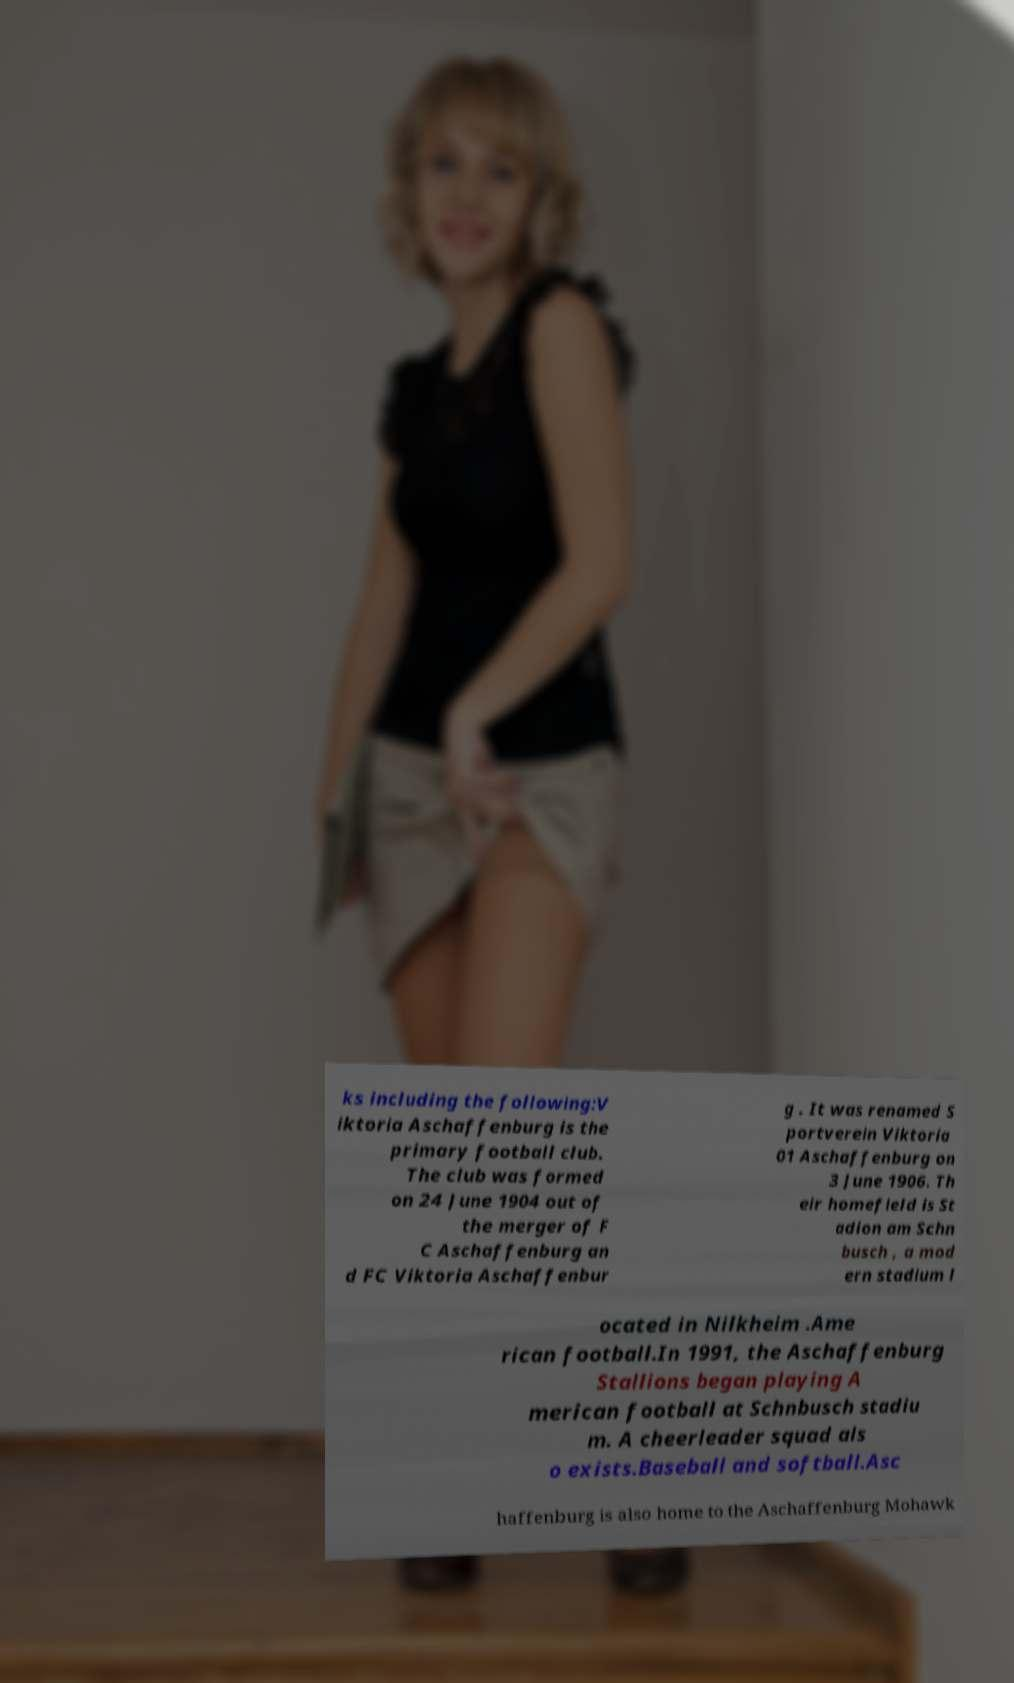I need the written content from this picture converted into text. Can you do that? ks including the following:V iktoria Aschaffenburg is the primary football club. The club was formed on 24 June 1904 out of the merger of F C Aschaffenburg an d FC Viktoria Aschaffenbur g . It was renamed S portverein Viktoria 01 Aschaffenburg on 3 June 1906. Th eir homefield is St adion am Schn busch , a mod ern stadium l ocated in Nilkheim .Ame rican football.In 1991, the Aschaffenburg Stallions began playing A merican football at Schnbusch stadiu m. A cheerleader squad als o exists.Baseball and softball.Asc haffenburg is also home to the Aschaffenburg Mohawk 